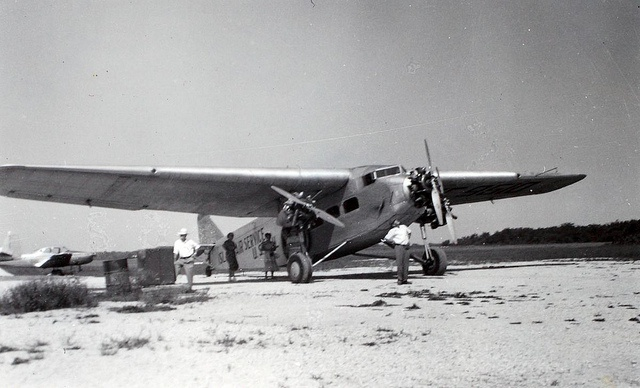Describe the objects in this image and their specific colors. I can see airplane in darkgray, gray, black, and lightgray tones, airplane in darkgray, lightgray, black, and gray tones, people in darkgray, gray, white, and black tones, people in darkgray, white, gray, and black tones, and people in darkgray, black, and gray tones in this image. 